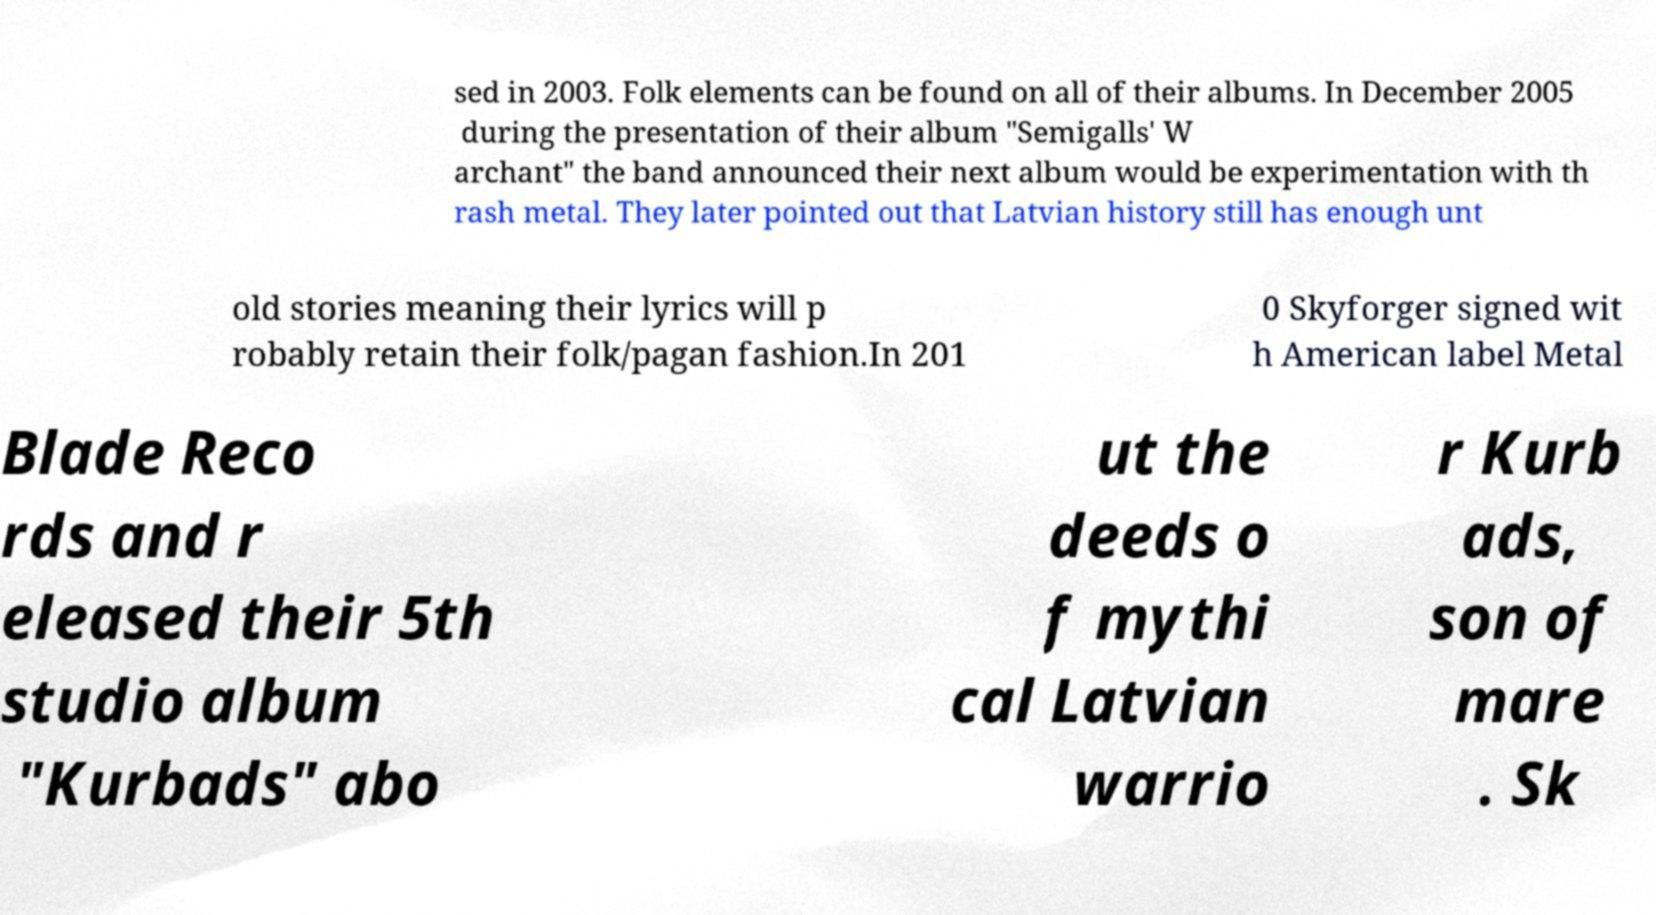I need the written content from this picture converted into text. Can you do that? sed in 2003. Folk elements can be found on all of their albums. In December 2005 during the presentation of their album "Semigalls' W archant" the band announced their next album would be experimentation with th rash metal. They later pointed out that Latvian history still has enough unt old stories meaning their lyrics will p robably retain their folk/pagan fashion.In 201 0 Skyforger signed wit h American label Metal Blade Reco rds and r eleased their 5th studio album "Kurbads" abo ut the deeds o f mythi cal Latvian warrio r Kurb ads, son of mare . Sk 